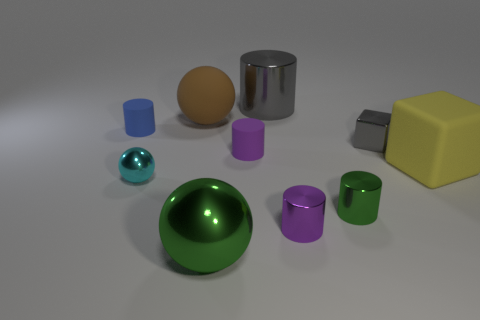Subtract all tiny green metal cylinders. How many cylinders are left? 4 Subtract all blue cylinders. How many cylinders are left? 4 Subtract all brown cylinders. Subtract all red blocks. How many cylinders are left? 5 Subtract all spheres. How many objects are left? 7 Add 1 large gray metal things. How many large gray metal things are left? 2 Add 6 large yellow matte things. How many large yellow matte things exist? 7 Subtract 1 blue cylinders. How many objects are left? 9 Subtract all large green spheres. Subtract all big metallic objects. How many objects are left? 7 